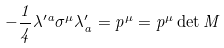<formula> <loc_0><loc_0><loc_500><loc_500>- \frac { 1 } { 4 } \lambda ^ { \prime a } \sigma ^ { \mu } \lambda ^ { \prime } _ { a } = p ^ { \mu } = p ^ { \mu } \det M</formula> 